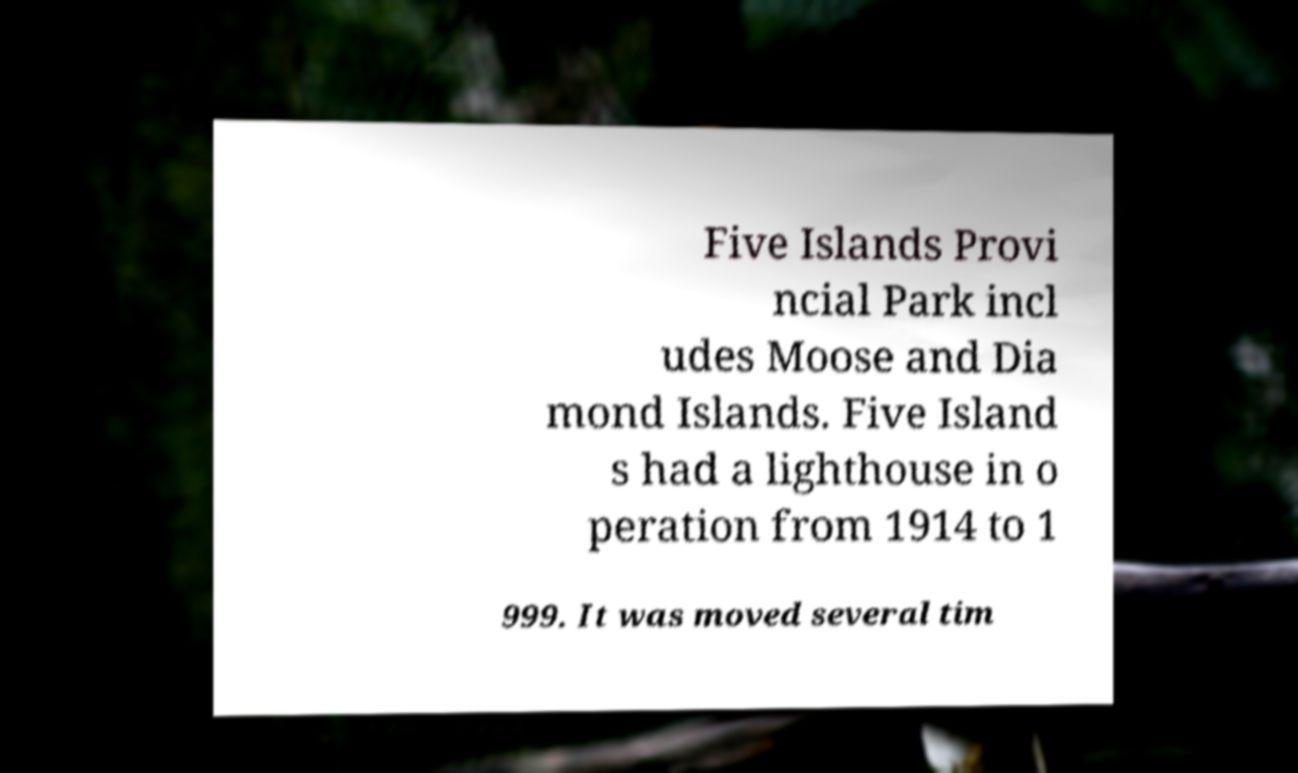What messages or text are displayed in this image? I need them in a readable, typed format. Five Islands Provi ncial Park incl udes Moose and Dia mond Islands. Five Island s had a lighthouse in o peration from 1914 to 1 999. It was moved several tim 